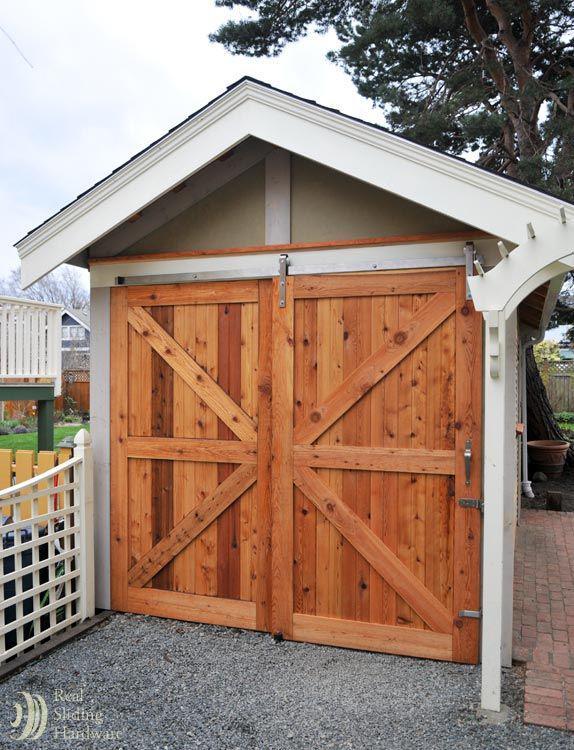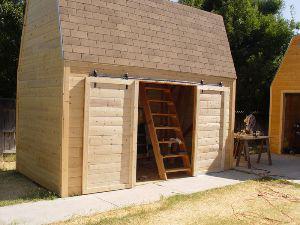The first image is the image on the left, the second image is the image on the right. Assess this claim about the two images: "An image depicts a barn door with diagonal crossed boards on the front.". Correct or not? Answer yes or no. Yes. 